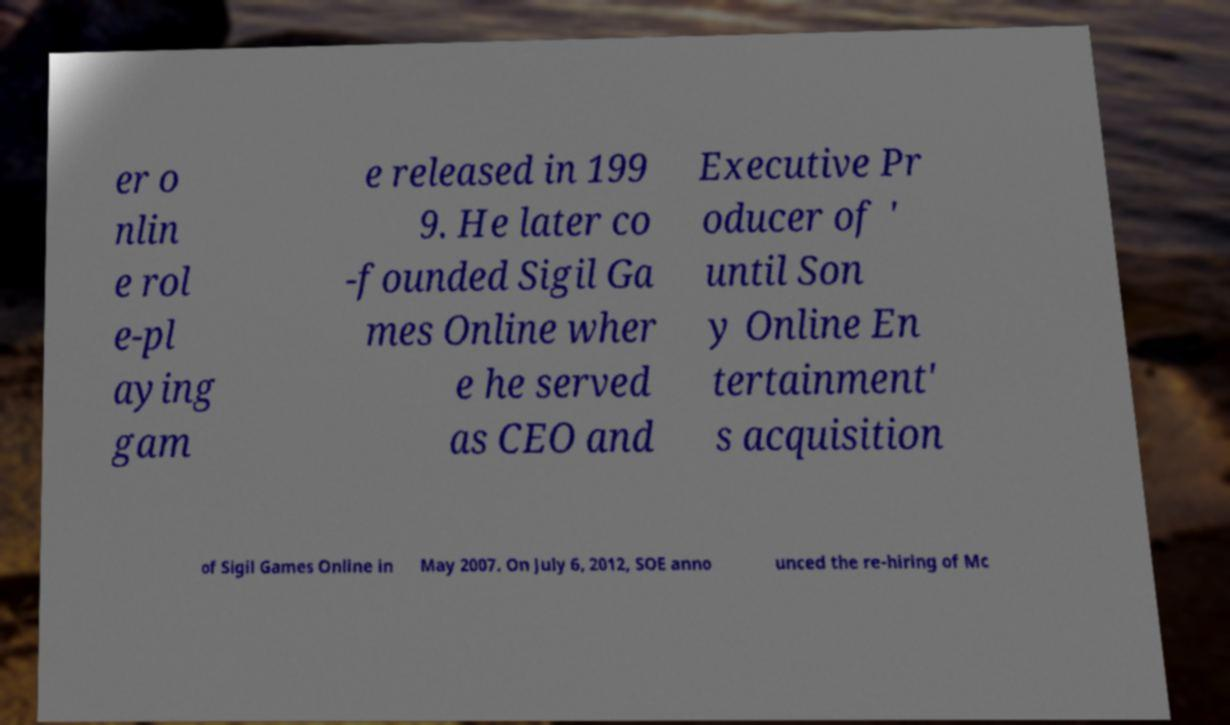Please identify and transcribe the text found in this image. er o nlin e rol e-pl aying gam e released in 199 9. He later co -founded Sigil Ga mes Online wher e he served as CEO and Executive Pr oducer of ' until Son y Online En tertainment' s acquisition of Sigil Games Online in May 2007. On July 6, 2012, SOE anno unced the re-hiring of Mc 